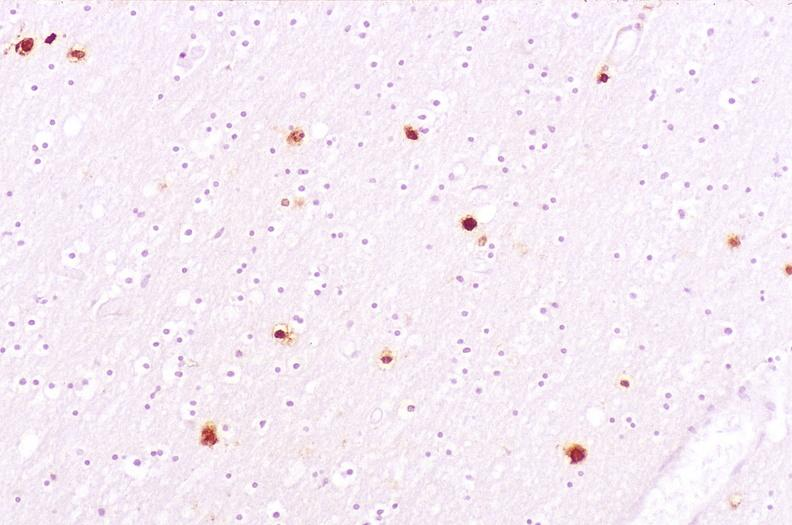does liver lesion show brain, herpes simplex encephalitis?
Answer the question using a single word or phrase. No 